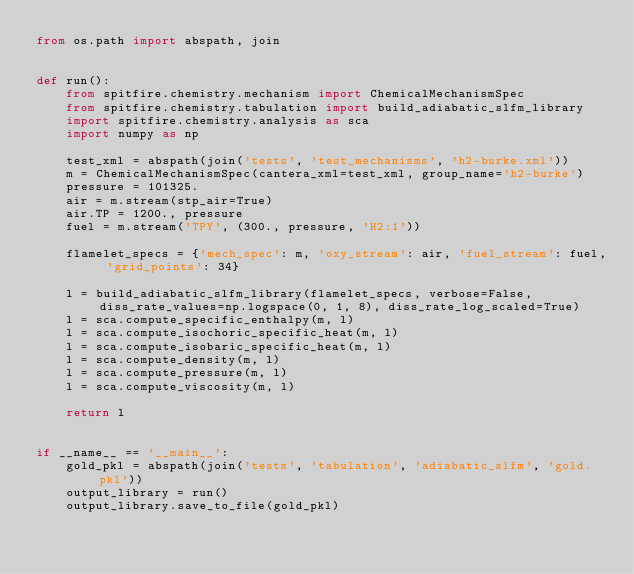Convert code to text. <code><loc_0><loc_0><loc_500><loc_500><_Python_>from os.path import abspath, join


def run():
    from spitfire.chemistry.mechanism import ChemicalMechanismSpec
    from spitfire.chemistry.tabulation import build_adiabatic_slfm_library
    import spitfire.chemistry.analysis as sca
    import numpy as np

    test_xml = abspath(join('tests', 'test_mechanisms', 'h2-burke.xml'))
    m = ChemicalMechanismSpec(cantera_xml=test_xml, group_name='h2-burke')
    pressure = 101325.
    air = m.stream(stp_air=True)
    air.TP = 1200., pressure
    fuel = m.stream('TPY', (300., pressure, 'H2:1'))

    flamelet_specs = {'mech_spec': m, 'oxy_stream': air, 'fuel_stream': fuel, 'grid_points': 34}

    l = build_adiabatic_slfm_library(flamelet_specs, verbose=False, diss_rate_values=np.logspace(0, 1, 8), diss_rate_log_scaled=True)
    l = sca.compute_specific_enthalpy(m, l)
    l = sca.compute_isochoric_specific_heat(m, l)
    l = sca.compute_isobaric_specific_heat(m, l)
    l = sca.compute_density(m, l)
    l = sca.compute_pressure(m, l)
    l = sca.compute_viscosity(m, l)

    return l


if __name__ == '__main__':
    gold_pkl = abspath(join('tests', 'tabulation', 'adiabatic_slfm', 'gold.pkl'))
    output_library = run()
    output_library.save_to_file(gold_pkl)
</code> 